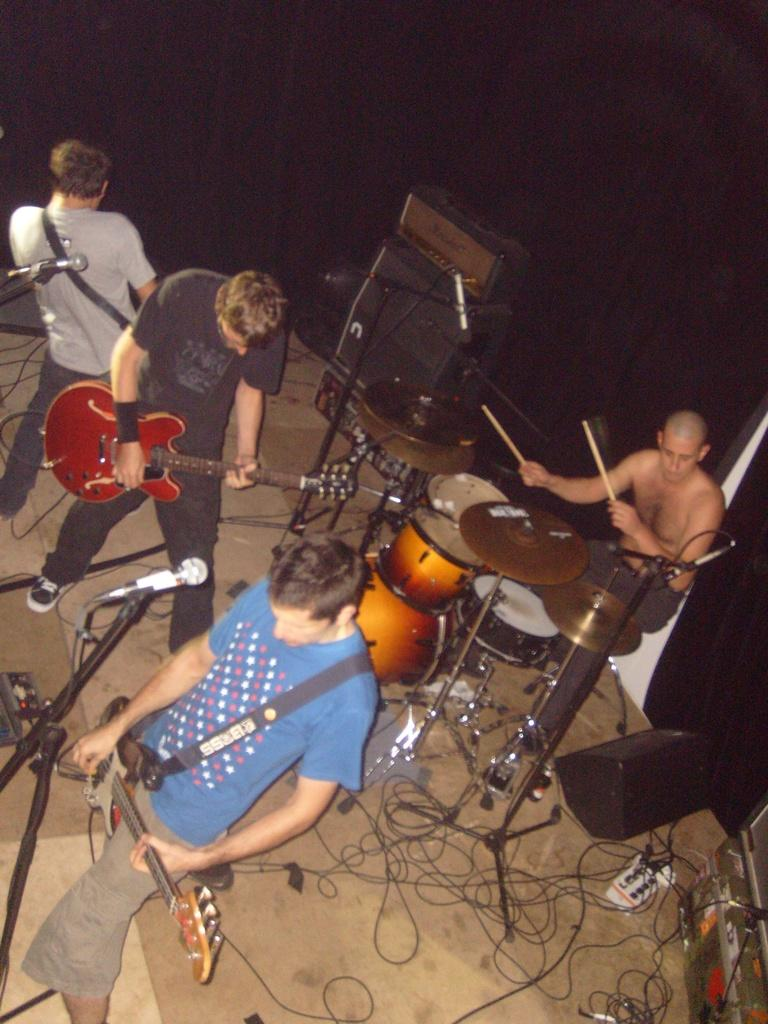What are the men in the image doing? The men in the image are playing guitars. What can be seen in front of the men? There is a microphone in front of the men. Is there another musician in the image? Yes, there is a person playing drums in the image. Where is the drum player positioned in relation to the guitar-playing men? The drum player is behind the guitar-playing men. What type of tomatoes can be seen growing in the lunchroom in the image? There are no tomatoes or lunchroom present in the image; it features a group of men playing guitars and a drummer. How many houses are visible in the image? There are no houses visible in the image; it features a group of musicians. 